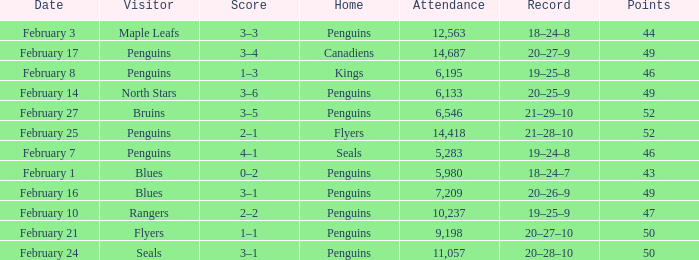Home of kings had what score? 1–3. 